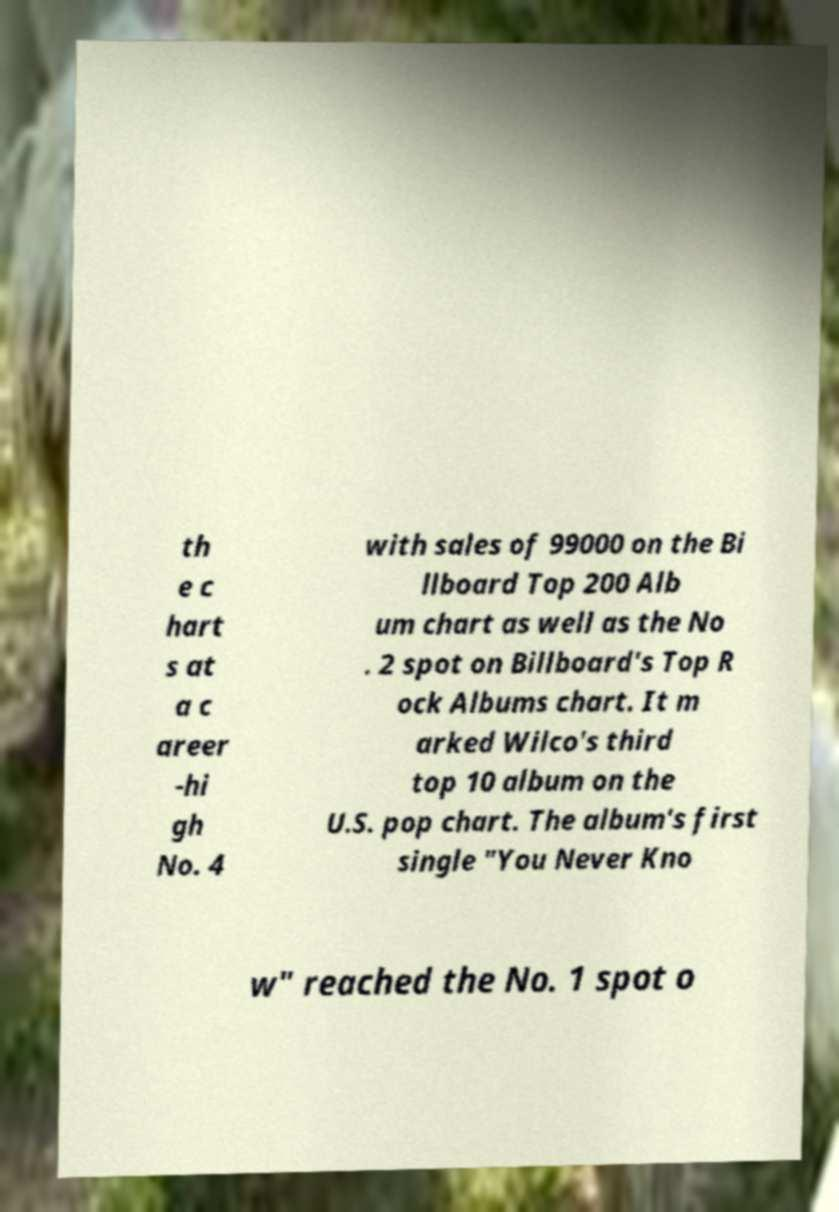There's text embedded in this image that I need extracted. Can you transcribe it verbatim? th e c hart s at a c areer -hi gh No. 4 with sales of 99000 on the Bi llboard Top 200 Alb um chart as well as the No . 2 spot on Billboard's Top R ock Albums chart. It m arked Wilco's third top 10 album on the U.S. pop chart. The album's first single "You Never Kno w" reached the No. 1 spot o 